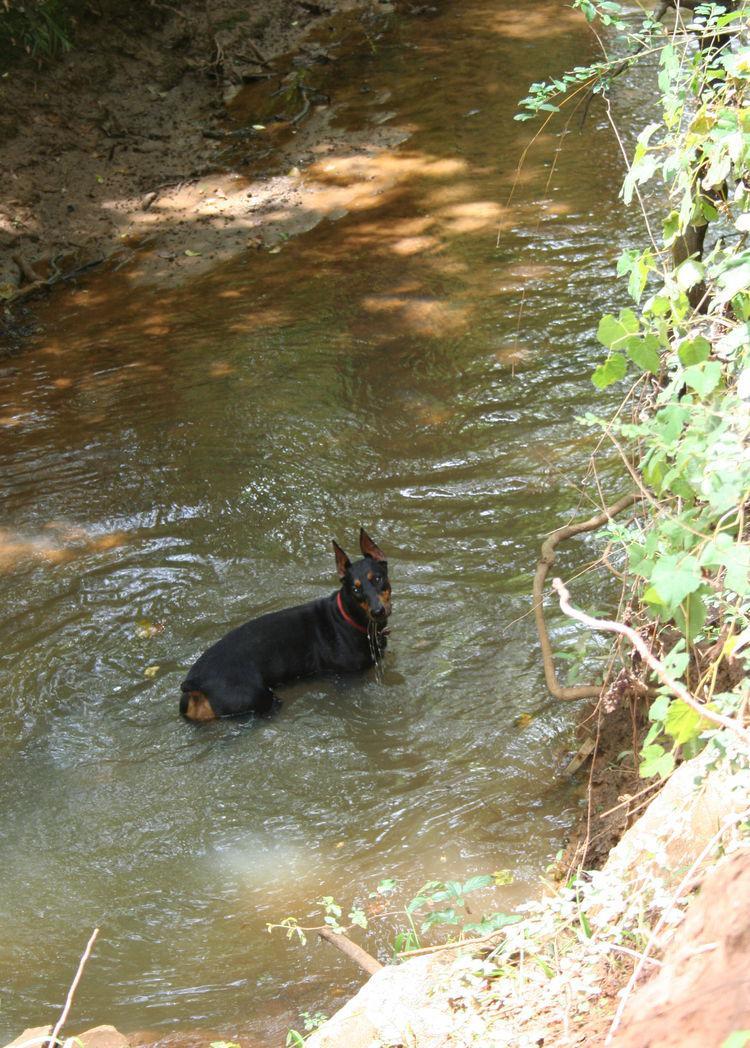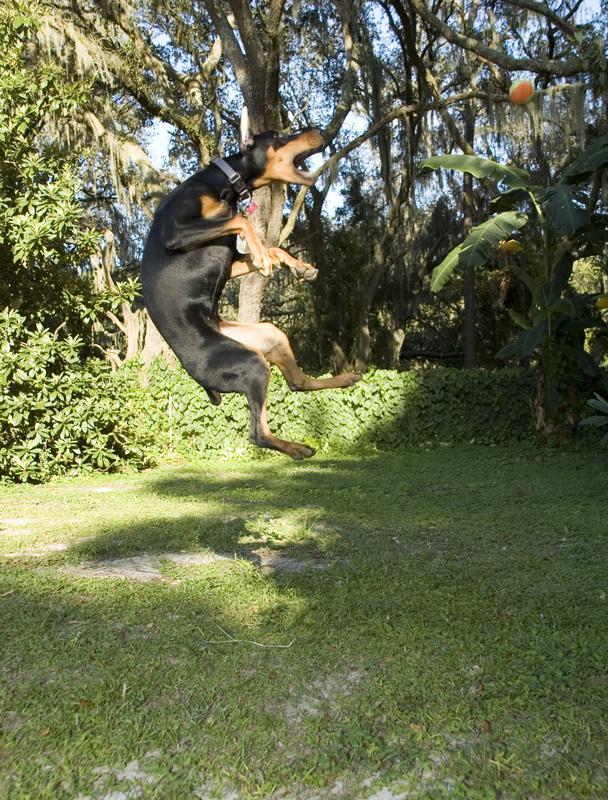The first image is the image on the left, the second image is the image on the right. For the images shown, is this caption "The right image shows a left-facing doberman creating a splash, with its front paws off the ground." true? Answer yes or no. No. The first image is the image on the left, the second image is the image on the right. Given the left and right images, does the statement "Three or more mammals are visible." hold true? Answer yes or no. No. 